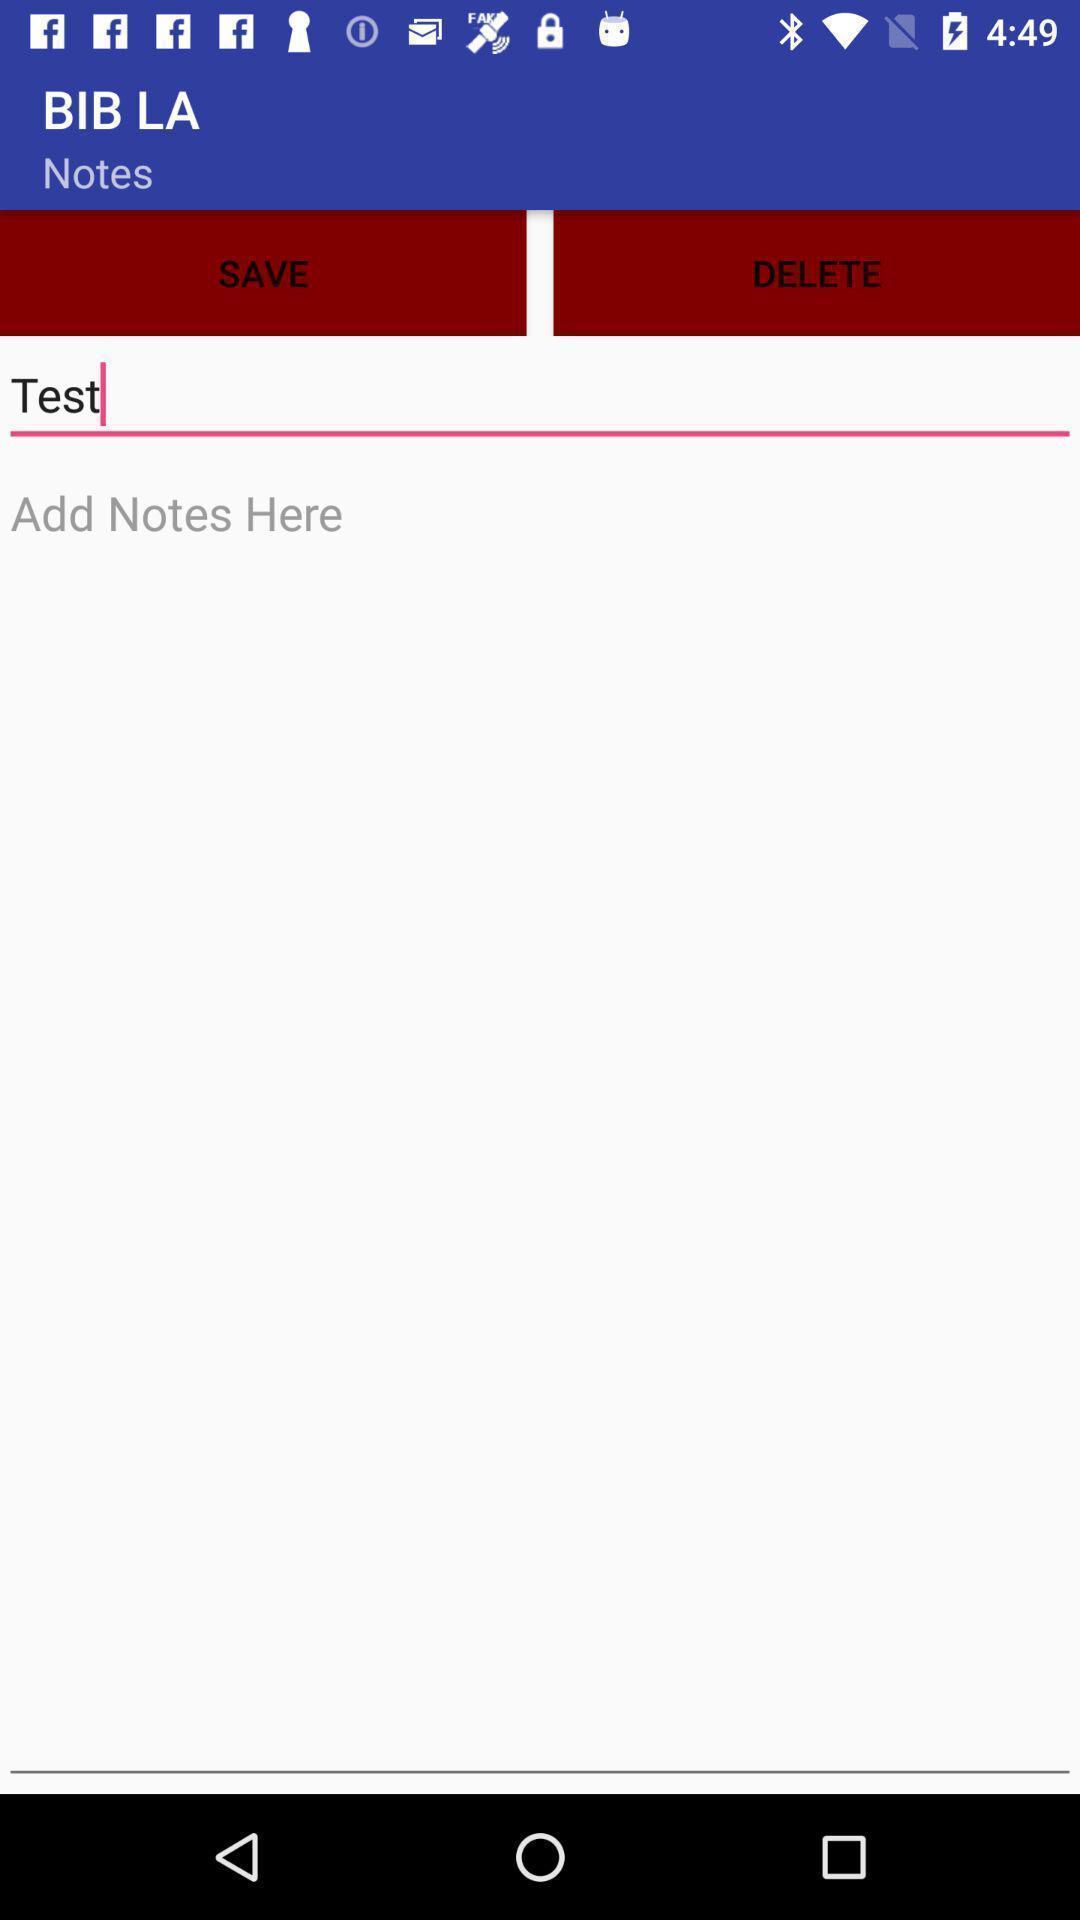Describe this image in words. Screen displaying add notes page. 